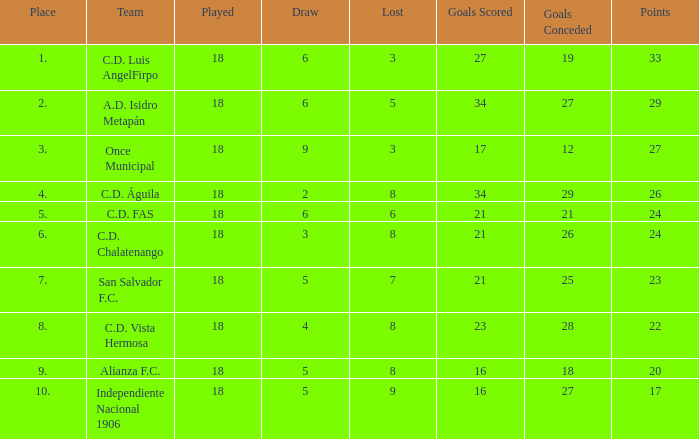Write the full table. {'header': ['Place', 'Team', 'Played', 'Draw', 'Lost', 'Goals Scored', 'Goals Conceded', 'Points'], 'rows': [['1.', 'C.D. Luis AngelFirpo', '18', '6', '3', '27', '19', '33'], ['2.', 'A.D. Isidro Metapán', '18', '6', '5', '34', '27', '29'], ['3.', 'Once Municipal', '18', '9', '3', '17', '12', '27'], ['4.', 'C.D. Águila', '18', '2', '8', '34', '29', '26'], ['5.', 'C.D. FAS', '18', '6', '6', '21', '21', '24'], ['6.', 'C.D. Chalatenango', '18', '3', '8', '21', '26', '24'], ['7.', 'San Salvador F.C.', '18', '5', '7', '21', '25', '23'], ['8.', 'C.D. Vista Hermosa', '18', '4', '8', '23', '28', '22'], ['9.', 'Alianza F.C.', '18', '5', '8', '16', '18', '20'], ['10.', 'Independiente Nacional 1906', '18', '5', '9', '16', '27', '17']]} In a game with a loss of 5 points, a placement greater than 2, and 27 goals conceded, how many points were there in total? 0.0. 